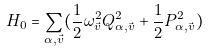Convert formula to latex. <formula><loc_0><loc_0><loc_500><loc_500>H _ { 0 } = \sum _ { \alpha , \vec { v } } ( \frac { 1 } { 2 } \omega ^ { 2 } _ { \vec { v } } Q ^ { 2 } _ { \alpha , \vec { v } } + \frac { 1 } { 2 } P ^ { 2 } _ { \alpha , \vec { v } } )</formula> 